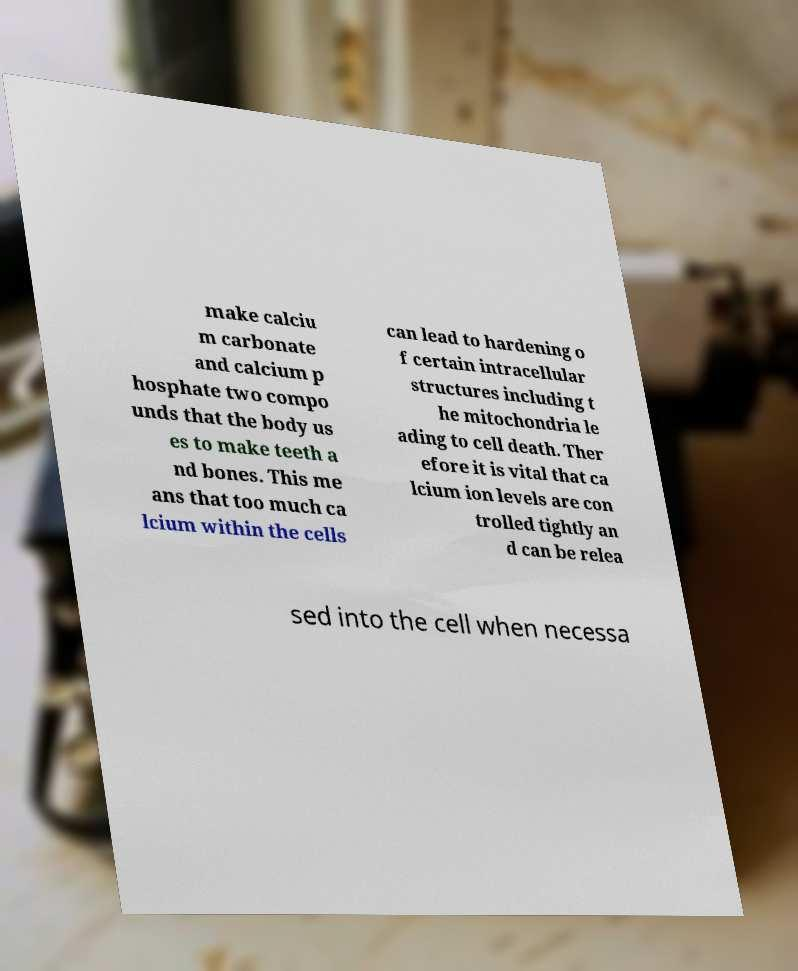What messages or text are displayed in this image? I need them in a readable, typed format. make calciu m carbonate and calcium p hosphate two compo unds that the body us es to make teeth a nd bones. This me ans that too much ca lcium within the cells can lead to hardening o f certain intracellular structures including t he mitochondria le ading to cell death. Ther efore it is vital that ca lcium ion levels are con trolled tightly an d can be relea sed into the cell when necessa 